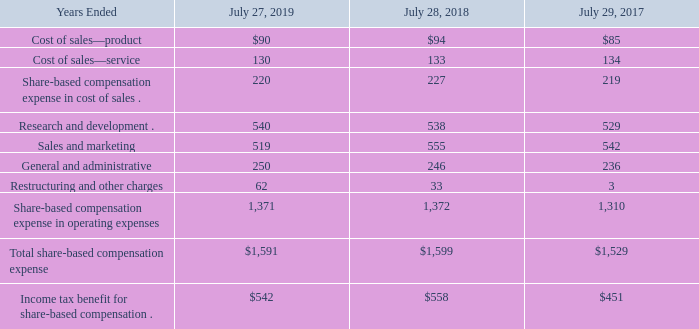(c) Summary of Share-Based Compensation Expense
Share-based compensation expense consists primarily of expenses for stock options, stock purchase rights, restricted stock, and RSUs granted to employees. The following table summarizes share-based compensation expense (in millions):
As of July 27, 2019, the total compensation cost related to unvested share-based awards not yet recognized was $3.3 billion, which is expected to be recognized over approximately 2.8 years on a weighted-average basis.
What was the total compensation cost related to unvested share-based awards not yet recognized as of 2019? $3.3 billion. What does share-based compensation expense consist of? Primarily of expenses for stock options, stock purchase rights, restricted stock, and rsus granted to employees. Which years does the table provide information for the company's share-based compensation expenses? 2019, 2018, 2017. What was the change in the product cost of sales between 2017 and 2018?
Answer scale should be: million. 94-85
Answer: 9. What was the total change in research and development between 2017 and 2019?
Answer scale should be: million. 540-529
Answer: 11. What was the percentage change in Total share-based compensation expense between 2018 and 2019?
Answer scale should be: percent. (1,591-1,599)/1,599
Answer: -0.5. 